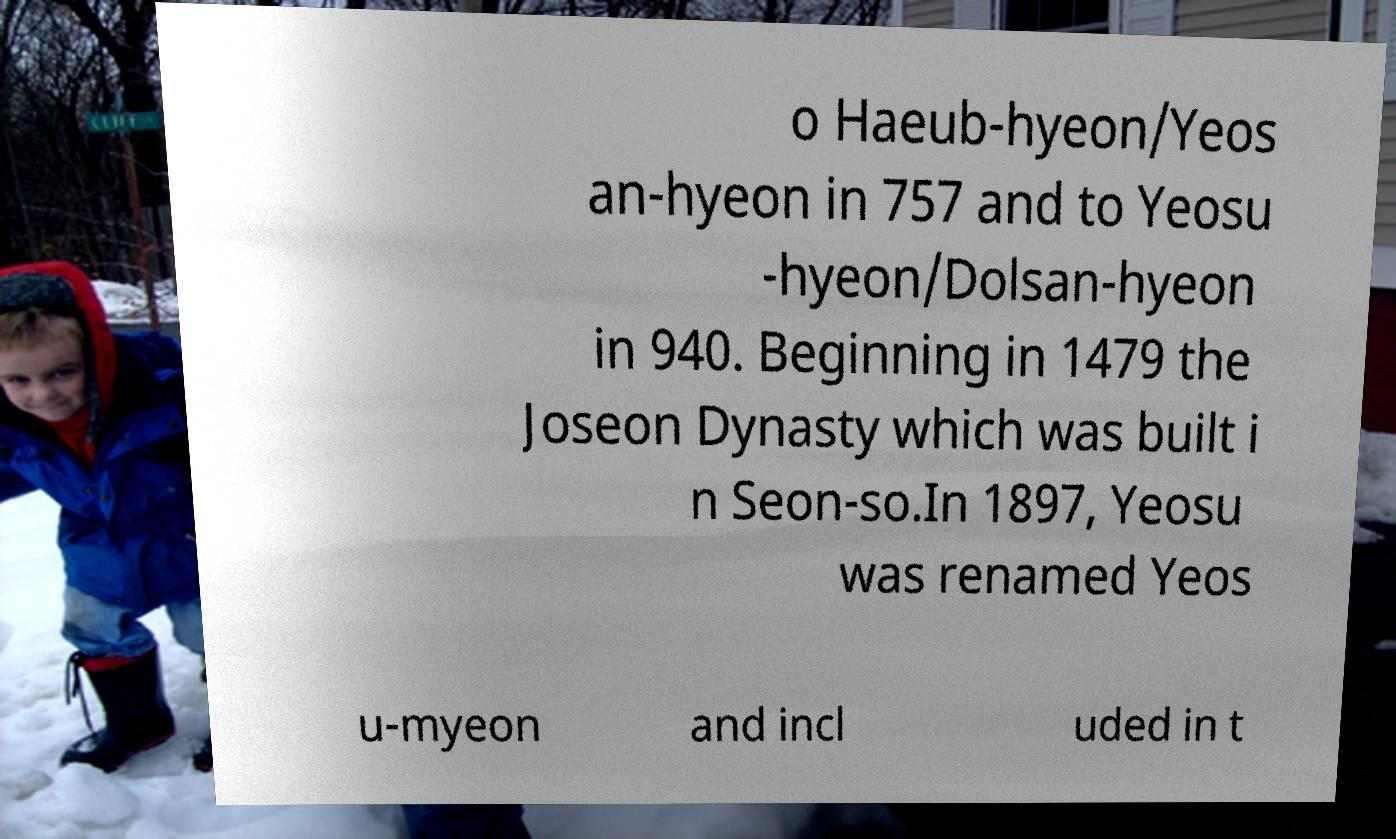Can you accurately transcribe the text from the provided image for me? o Haeub-hyeon/Yeos an-hyeon in 757 and to Yeosu -hyeon/Dolsan-hyeon in 940. Beginning in 1479 the Joseon Dynasty which was built i n Seon-so.In 1897, Yeosu was renamed Yeos u-myeon and incl uded in t 